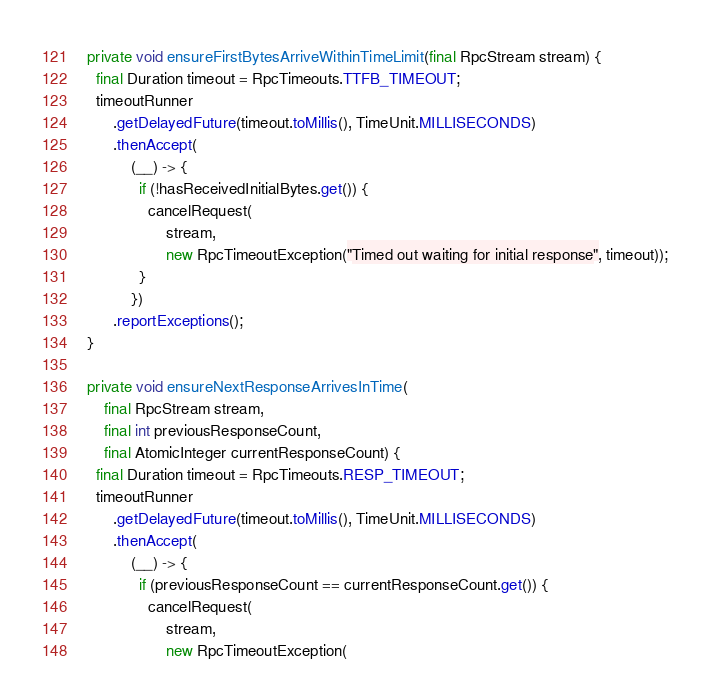<code> <loc_0><loc_0><loc_500><loc_500><_Java_>  private void ensureFirstBytesArriveWithinTimeLimit(final RpcStream stream) {
    final Duration timeout = RpcTimeouts.TTFB_TIMEOUT;
    timeoutRunner
        .getDelayedFuture(timeout.toMillis(), TimeUnit.MILLISECONDS)
        .thenAccept(
            (__) -> {
              if (!hasReceivedInitialBytes.get()) {
                cancelRequest(
                    stream,
                    new RpcTimeoutException("Timed out waiting for initial response", timeout));
              }
            })
        .reportExceptions();
  }

  private void ensureNextResponseArrivesInTime(
      final RpcStream stream,
      final int previousResponseCount,
      final AtomicInteger currentResponseCount) {
    final Duration timeout = RpcTimeouts.RESP_TIMEOUT;
    timeoutRunner
        .getDelayedFuture(timeout.toMillis(), TimeUnit.MILLISECONDS)
        .thenAccept(
            (__) -> {
              if (previousResponseCount == currentResponseCount.get()) {
                cancelRequest(
                    stream,
                    new RpcTimeoutException(</code> 